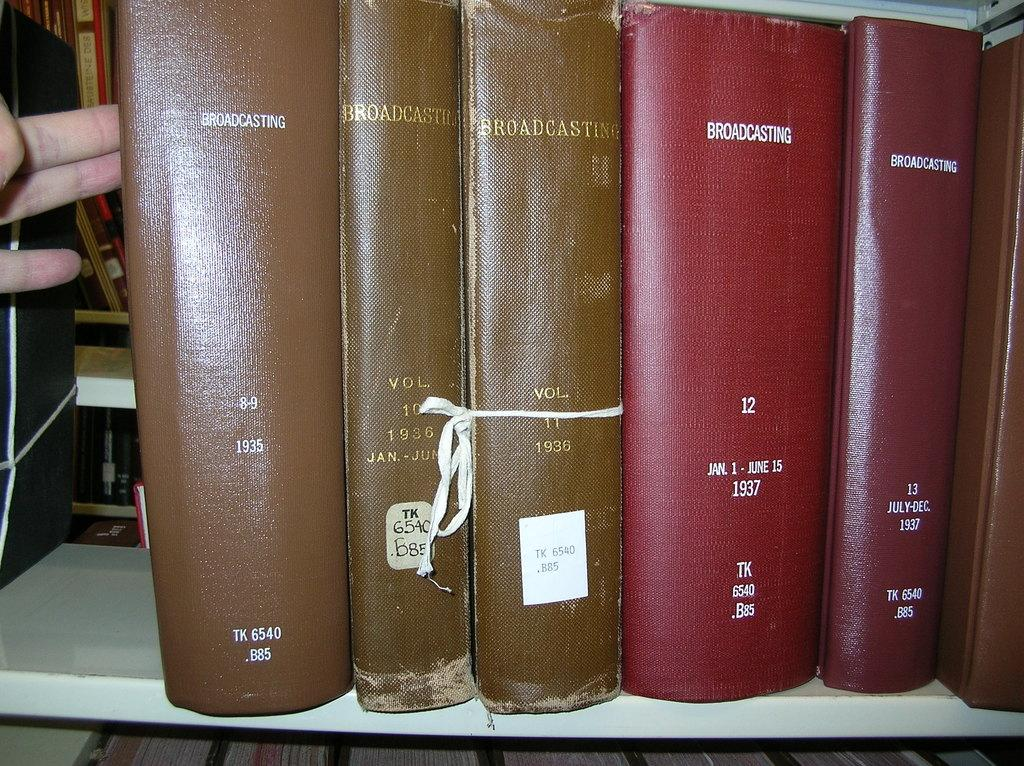What is the human hand in the image touching? The human hand is touching a book in the image. Can you describe the book being touched? The book is brown in color. What else can be seen in the image besides the hand and the book? There is a white-colored rack in the image. What is the purpose of the white-colored rack? The white-colored rack contains multiple books. How many pizzas are on the rack in the image? There are no pizzas present in the image; it features a human hand touching a brown book and a white-colored rack containing multiple books. 